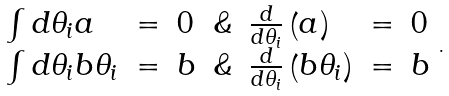Convert formula to latex. <formula><loc_0><loc_0><loc_500><loc_500>\begin{array} { l c l c l c l } \int d \theta _ { i } a & = & 0 & \& & \frac { d } { d \theta _ { i } } \left ( a \right ) & = & 0 \\ \int d \theta _ { i } b \theta _ { i } & = & b & \& & \frac { d } { d \theta _ { i } } \left ( b \theta _ { i } \right ) & = & b \end{array} .</formula> 